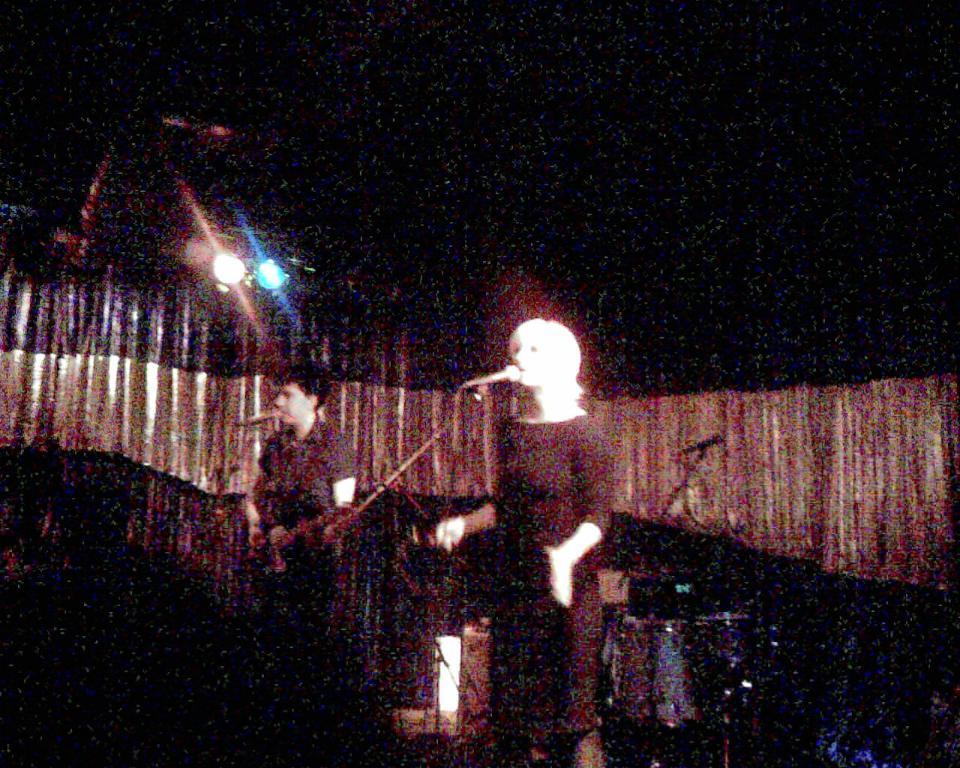How many people are in the image? There are two persons in the image. What are the persons doing in the image? The persons are singing a song. What objects are in front of the persons? There are microphones in front of the persons. What can be seen at the back side of the image? There are curtains, lights, and drums at the back side of the image. Are there any other objects visible at the back side of the image? Yes, there are other objects at the back side of the image. What type of books are the persons reading in the image? There are no books present in the image; the persons are singing a song. 